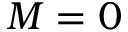Convert formula to latex. <formula><loc_0><loc_0><loc_500><loc_500>M = 0</formula> 